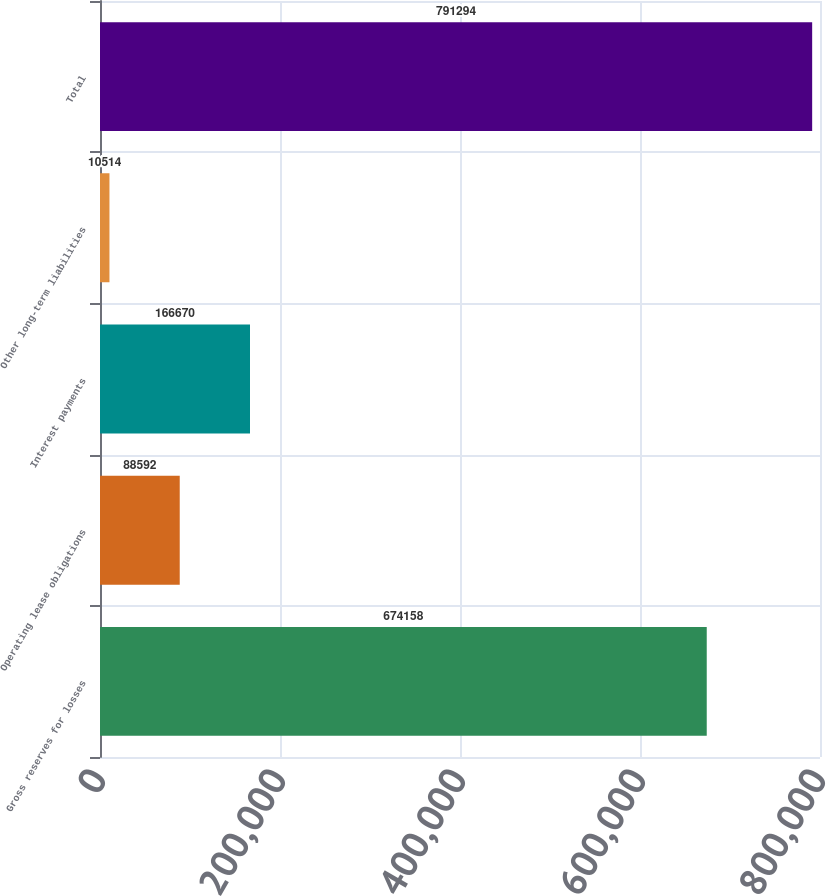<chart> <loc_0><loc_0><loc_500><loc_500><bar_chart><fcel>Gross reserves for losses<fcel>Operating lease obligations<fcel>Interest payments<fcel>Other long-term liabilities<fcel>Total<nl><fcel>674158<fcel>88592<fcel>166670<fcel>10514<fcel>791294<nl></chart> 